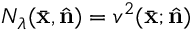<formula> <loc_0><loc_0><loc_500><loc_500>N _ { \lambda } ( \bar { x } , \hat { n } ) = v ^ { 2 } ( \bar { x } ; \hat { n } )</formula> 